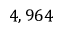<formula> <loc_0><loc_0><loc_500><loc_500>4 , 9 6 4</formula> 